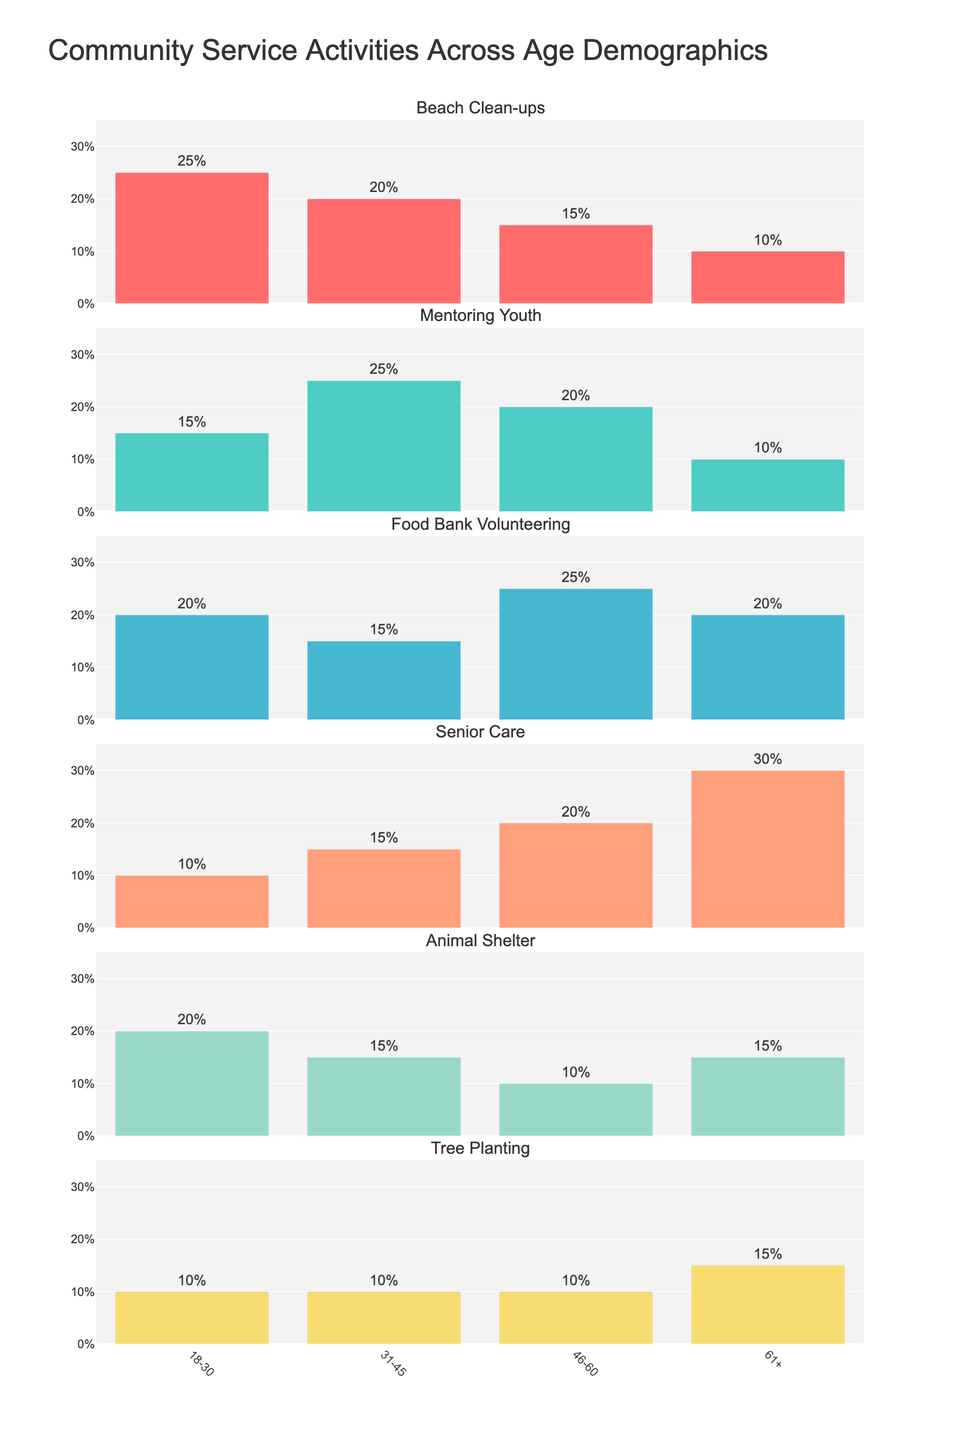Which age group has the highest percentage of mentoring youth? To find which age group has the highest percentage for mentoring youth, look at the bars in the row labeled "Mentoring Youth". The highest bar corresponds to the percentage for the 31-45 age group.
Answer: 31-45 What is the average percentage of food bank volunteering across all age groups? The percentage of food bank volunteering for each age group is: 20, 15, 25, and 20. Add these values and divide by the number of groups: (20 + 15 + 25 + 20) / 4 = 80 / 4 = 20
Answer: 20 Which age group contributes the least to beach clean-ups? To determine the age group with the least contribution to beach clean-ups, examine the height of the bars in the "Beach Clean-ups" row. The 61+ age group has the smallest bar at 10%.
Answer: 61+ What is the difference in percentage between the 46-60 and 61+ age groups for senior care? The percentage for senior care in the 46-60 age group is 20%, and for the 61+ age group, it is 30%. The difference is 30% - 20% = 10%.
Answer: 10 What is the most participated activity for the 18-30 age group? Look at the bars corresponding to the 18-30 age group across all activities. Beach clean-ups and Animal Shelter both have the highest percentage at 25%.
Answer: Beach Clean-ups and Animal Shelter Which activity shows the highest percentage for the 46-60 age group? Check the bars for the 46-60 age group across different subplots. The highest bar is for Food Bank Volunteering at 25%.
Answer: Food Bank Volunteering How many percentage points higher is senior care than tree planting for the 61+ age group? The percentage for senior care in the 61+ age group is 30%, and for tree planting, it is 15%. The difference is 30% - 15% = 15%.
Answer: 15 In which activity do the 31-45 and 46-60 age groups have the same percentage? Explore the values from the figure to see where the values are equal between 31-45 and 46-60. For Tree Planting, both have a contribution of 10%.
Answer: Tree Planting 